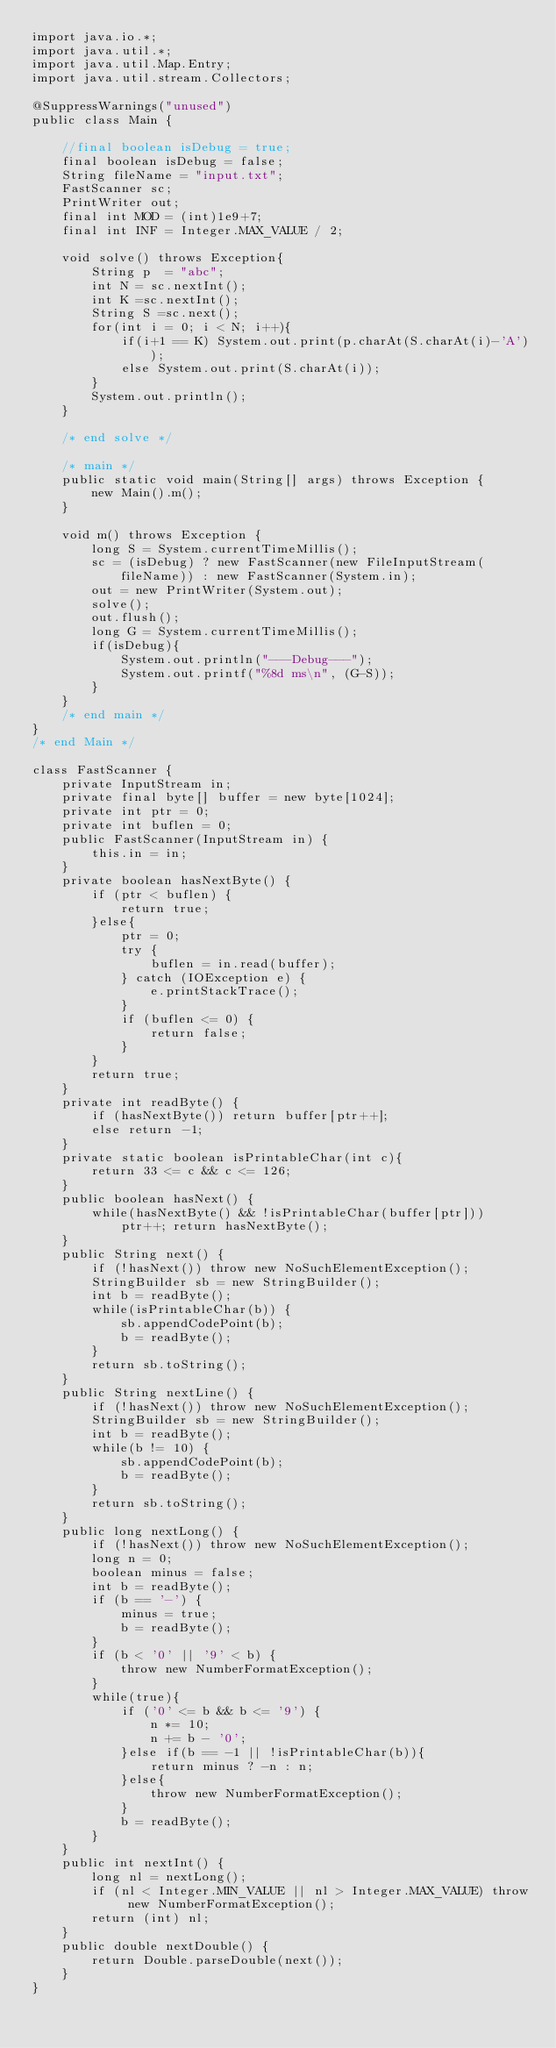Convert code to text. <code><loc_0><loc_0><loc_500><loc_500><_Java_>import java.io.*;
import java.util.*;
import java.util.Map.Entry;
import java.util.stream.Collectors;

@SuppressWarnings("unused")
public class Main {
	
	//final boolean isDebug = true;
	final boolean isDebug = false;
	String fileName = "input.txt";
	FastScanner sc;
	PrintWriter out;
	final int MOD = (int)1e9+7;
	final int INF = Integer.MAX_VALUE / 2;
	
	void solve() throws Exception{
		String p  = "abc";
		int N = sc.nextInt();
		int K =sc.nextInt();
		String S =sc.next();
		for(int i = 0; i < N; i++){
			if(i+1 == K) System.out.print(p.charAt(S.charAt(i)-'A'));
			else System.out.print(S.charAt(i));
		}
		System.out.println();
	}
	
	/* end solve */
	
	/* main */
	public static void main(String[] args) throws Exception {
		new Main().m();
	}
	
	void m() throws Exception {
		long S = System.currentTimeMillis();
		sc = (isDebug) ? new FastScanner(new FileInputStream(fileName)) : new FastScanner(System.in);
		out = new PrintWriter(System.out);
		solve();
		out.flush();
		long G = System.currentTimeMillis();
		if(isDebug){
			System.out.println("---Debug---");
			System.out.printf("%8d ms\n", (G-S));
		}
	}
	/* end main */
}
/* end Main */

class FastScanner {
    private InputStream in;
    private final byte[] buffer = new byte[1024];
    private int ptr = 0;
    private int buflen = 0;
    public FastScanner(InputStream in) {
		this.in = in;
	}
    private boolean hasNextByte() {
        if (ptr < buflen) {
            return true;
        }else{
            ptr = 0;
            try {
                buflen = in.read(buffer);
            } catch (IOException e) {
                e.printStackTrace();
            }
            if (buflen <= 0) {
                return false;
            }
        }
        return true;
    }
    private int readByte() {
    	if (hasNextByte()) return buffer[ptr++];
    	else return -1;
    }
    private static boolean isPrintableChar(int c){
    	return 33 <= c && c <= 126;
    }
    public boolean hasNext() {
    	while(hasNextByte() && !isPrintableChar(buffer[ptr]))
    		ptr++; return hasNextByte();
    }
    public String next() {
        if (!hasNext()) throw new NoSuchElementException();
        StringBuilder sb = new StringBuilder();
        int b = readByte();
        while(isPrintableChar(b)) {
            sb.appendCodePoint(b);
            b = readByte();
        }
        return sb.toString();
    }
    public String nextLine() {
        if (!hasNext()) throw new NoSuchElementException();
        StringBuilder sb = new StringBuilder();
        int b = readByte();
        while(b != 10) {
            sb.appendCodePoint(b);
            b = readByte();
        }
        return sb.toString();
    }
    public long nextLong() {
        if (!hasNext()) throw new NoSuchElementException();
        long n = 0;
        boolean minus = false;
        int b = readByte();
        if (b == '-') {
            minus = true;
            b = readByte();
        }
        if (b < '0' || '9' < b) {
            throw new NumberFormatException();
        }
        while(true){
            if ('0' <= b && b <= '9') {
                n *= 10;
                n += b - '0';
            }else if(b == -1 || !isPrintableChar(b)){
                return minus ? -n : n;
            }else{
                throw new NumberFormatException();
            }
            b = readByte();
        }
    }
    public int nextInt() {
        long nl = nextLong();
        if (nl < Integer.MIN_VALUE || nl > Integer.MAX_VALUE) throw new NumberFormatException();
        return (int) nl;
    }
    public double nextDouble() {
    	return Double.parseDouble(next());
    }
}</code> 